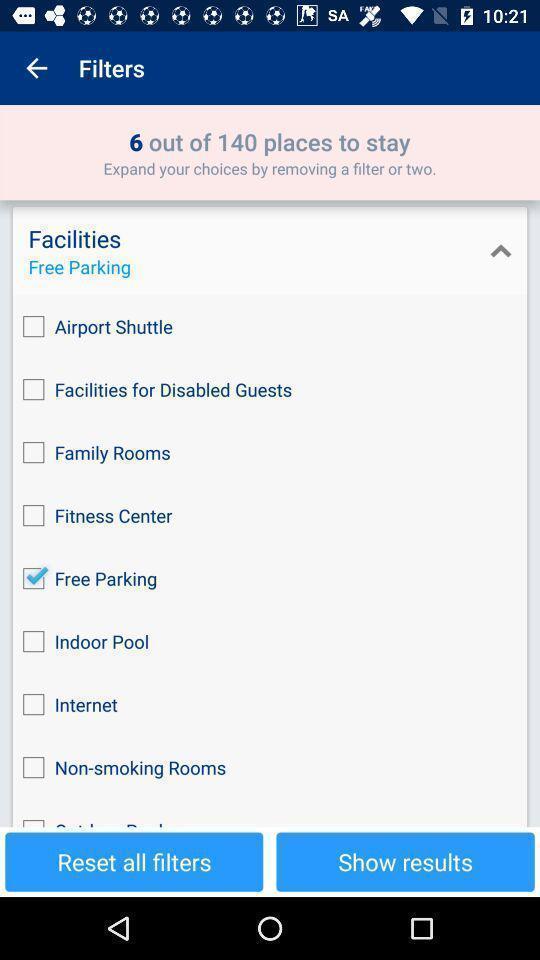Provide a textual representation of this image. Screen displaying multiple filter options. 